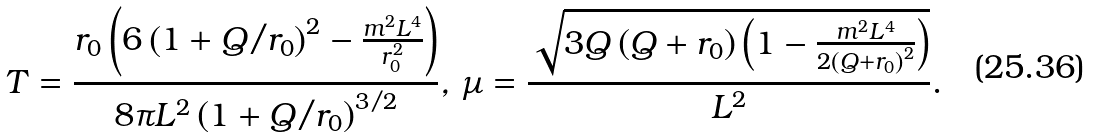<formula> <loc_0><loc_0><loc_500><loc_500>T = \frac { r _ { 0 } \left ( 6 \left ( 1 + Q / r _ { 0 } \right ) ^ { 2 } - \frac { m ^ { 2 } L ^ { 4 } } { r _ { 0 } ^ { 2 } } \right ) } { 8 \pi L ^ { 2 } \left ( 1 + Q / r _ { 0 } \right ) ^ { 3 / 2 } } , \, \mu = \frac { \sqrt { 3 Q \left ( Q + r _ { 0 } \right ) \left ( 1 - \frac { m ^ { 2 } L ^ { 4 } } { 2 \left ( Q + r _ { 0 } \right ) ^ { 2 } } \right ) } } { L ^ { 2 } } .</formula> 